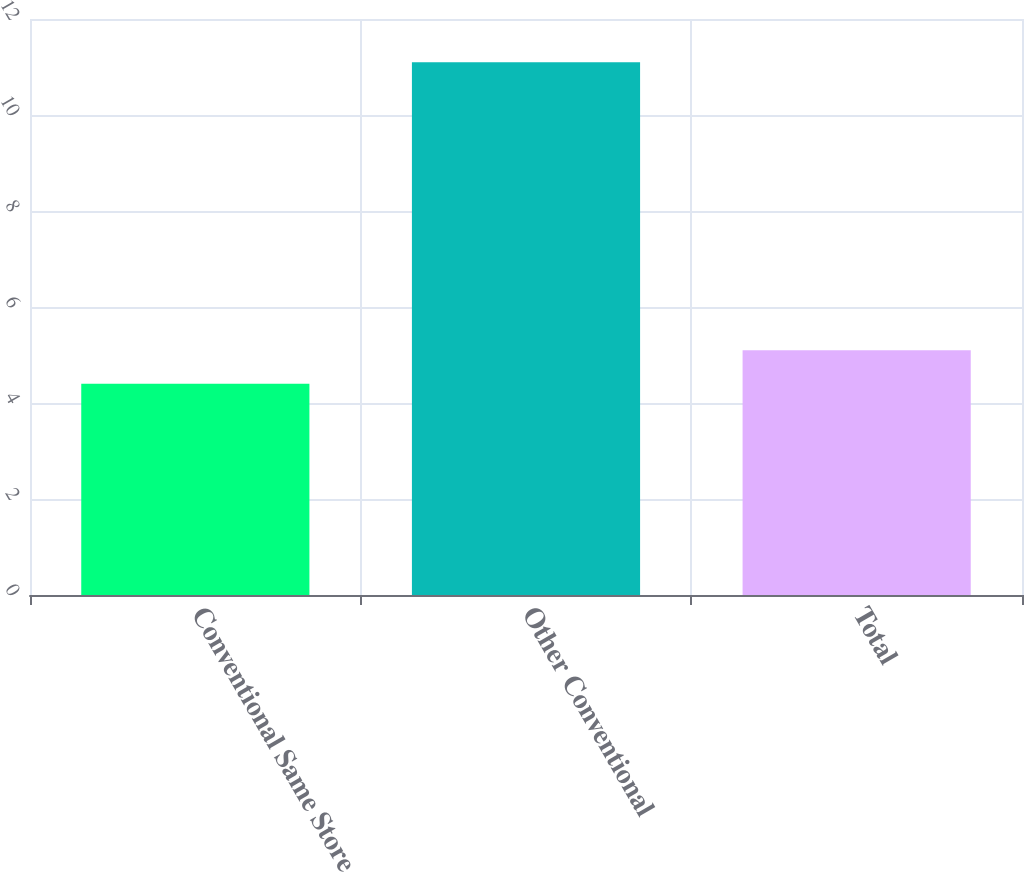Convert chart to OTSL. <chart><loc_0><loc_0><loc_500><loc_500><bar_chart><fcel>Conventional Same Store<fcel>Other Conventional<fcel>Total<nl><fcel>4.4<fcel>11.1<fcel>5.1<nl></chart> 